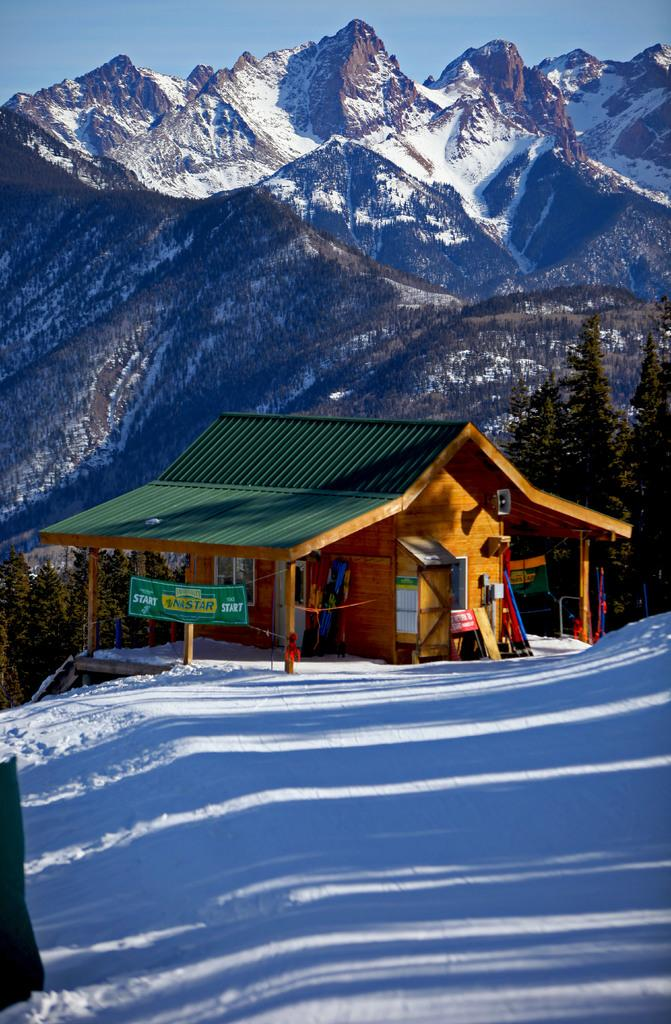What type of structure is present in the image? There is a house in the image. What decorations or signs can be seen in the image? There are banners and boards in the image. What is the weather like in the image? There is snow in the image. What type of vegetation is present in the image? There are trees in the image. What can be seen in the distance in the image? There are mountains visible in the background of the image. What is visible in the sky in the image? The sky is visible in the background of the image. What type of education is being protested in the image? There is no protest or reference to education in the image; it features a house, banners, boards, snow, trees, mountains, and the sky. 